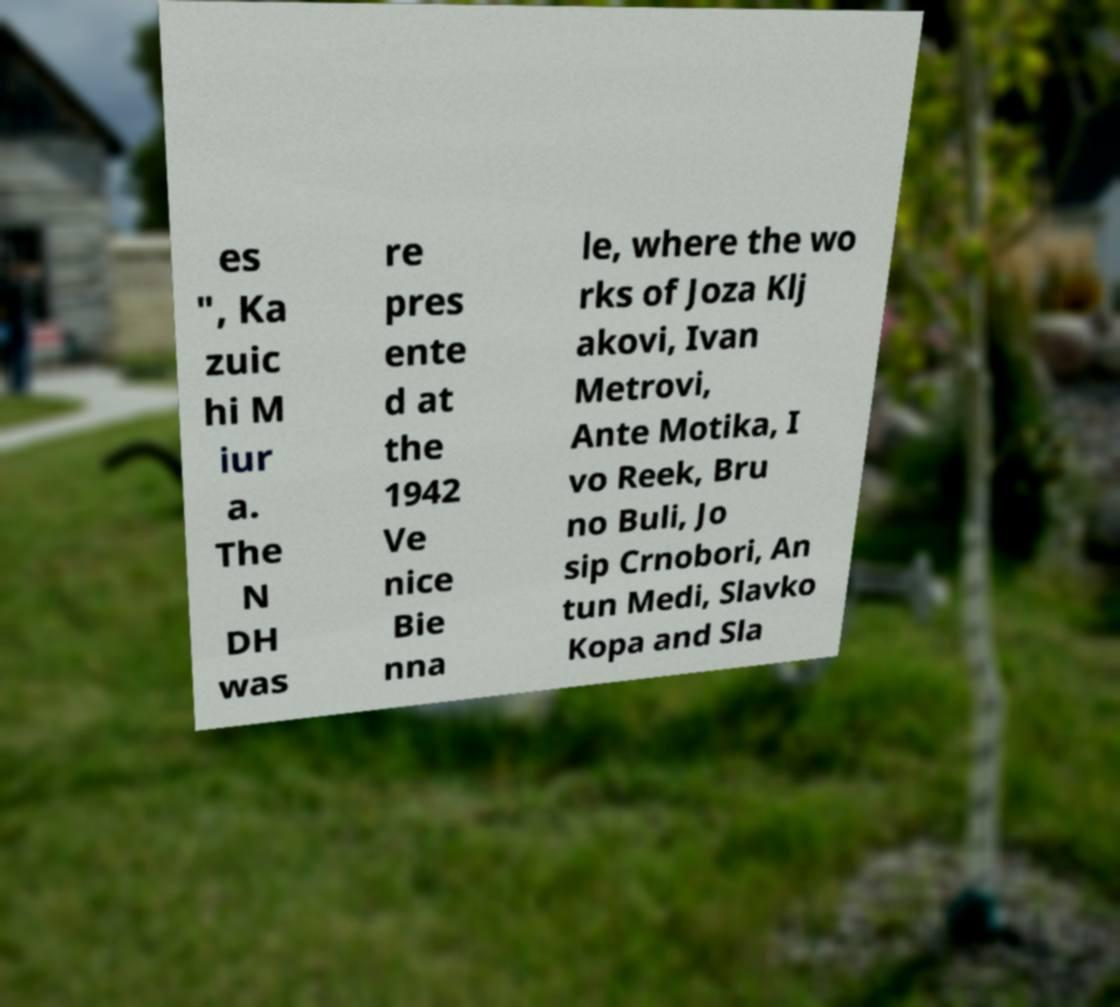What messages or text are displayed in this image? I need them in a readable, typed format. es ", Ka zuic hi M iur a. The N DH was re pres ente d at the 1942 Ve nice Bie nna le, where the wo rks of Joza Klj akovi, Ivan Metrovi, Ante Motika, I vo Reek, Bru no Buli, Jo sip Crnobori, An tun Medi, Slavko Kopa and Sla 